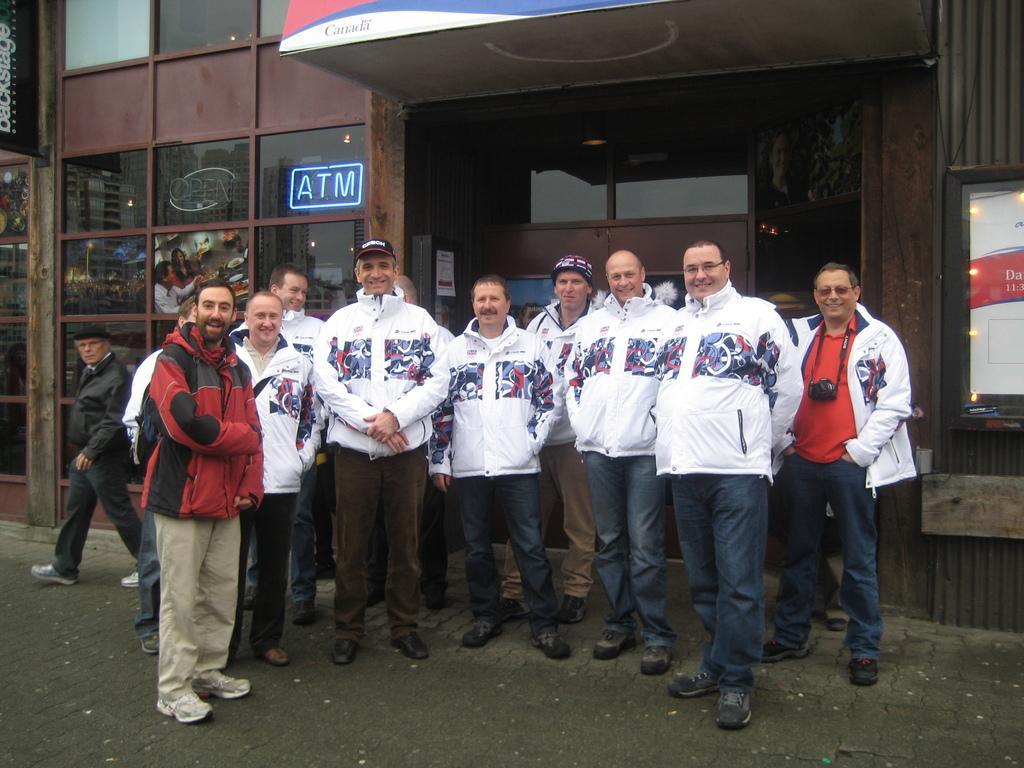How would you summarize this image in a sentence or two? In the image we can see there are people standing and one is walking. They are wearing clothes, shoes and some of them are wearing spectacles and caps. Here we can see the road and the building. Here we can see the posts and led text. 